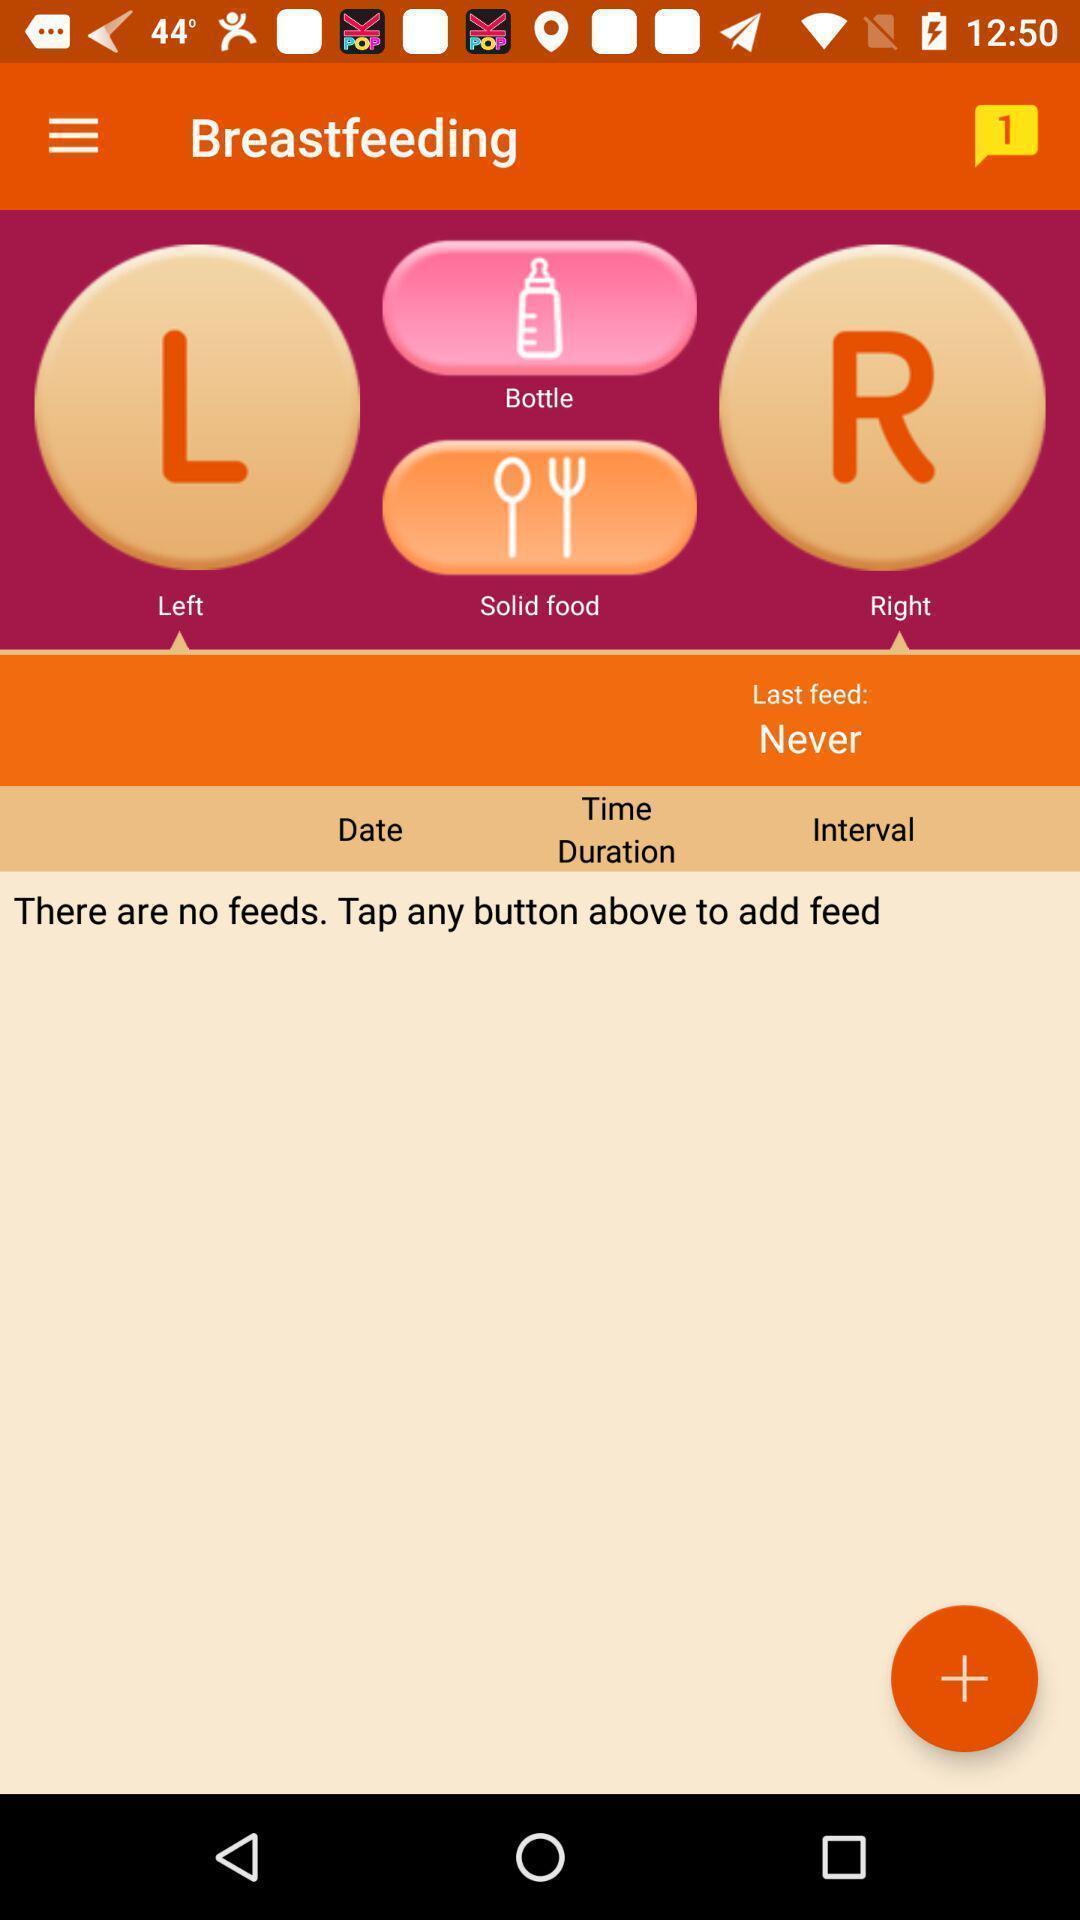Describe the key features of this screenshot. Screen displaying about feeding application. 